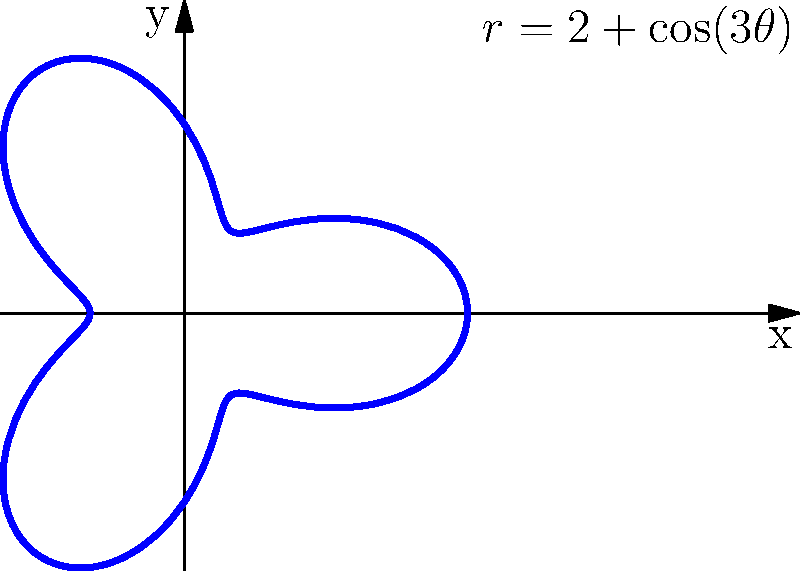You're designing a unique chest piece for your next cosplay costume. The shape of the piece can be represented in polar coordinates by the equation $r = 2 + \cos(3\theta)$, where $r$ is in inches. Calculate the area of this costume piece using polar integration. To find the area of the costume piece, we need to use the formula for area in polar coordinates:

$$ A = \frac{1}{2} \int_{0}^{2\pi} r^2 d\theta $$

Given equation: $r = 2 + \cos(3\theta)$

Step 1: Square the radius function
$$ r^2 = (2 + \cos(3\theta))^2 = 4 + 4\cos(3\theta) + \cos^2(3\theta) $$

Step 2: Substitute into the area formula
$$ A = \frac{1}{2} \int_{0}^{2\pi} (4 + 4\cos(3\theta) + \cos^2(3\theta)) d\theta $$

Step 3: Integrate each term
- $\int_{0}^{2\pi} 4 d\theta = 4\theta \big|_{0}^{2\pi} = 8\pi$
- $\int_{0}^{2\pi} 4\cos(3\theta) d\theta = \frac{4}{3}\sin(3\theta) \big|_{0}^{2\pi} = 0$
- $\int_{0}^{2\pi} \cos^2(3\theta) d\theta = \frac{1}{2}\int_{0}^{2\pi} (1 + \cos(6\theta)) d\theta = \frac{1}{2}(\theta + \frac{1}{6}\sin(6\theta)) \big|_{0}^{2\pi} = \pi$

Step 4: Sum up the results and multiply by $\frac{1}{2}$
$$ A = \frac{1}{2} (8\pi + 0 + \pi) = \frac{9\pi}{2} $$

Therefore, the area of the costume piece is $\frac{9\pi}{2}$ square inches.
Answer: $\frac{9\pi}{2}$ square inches 